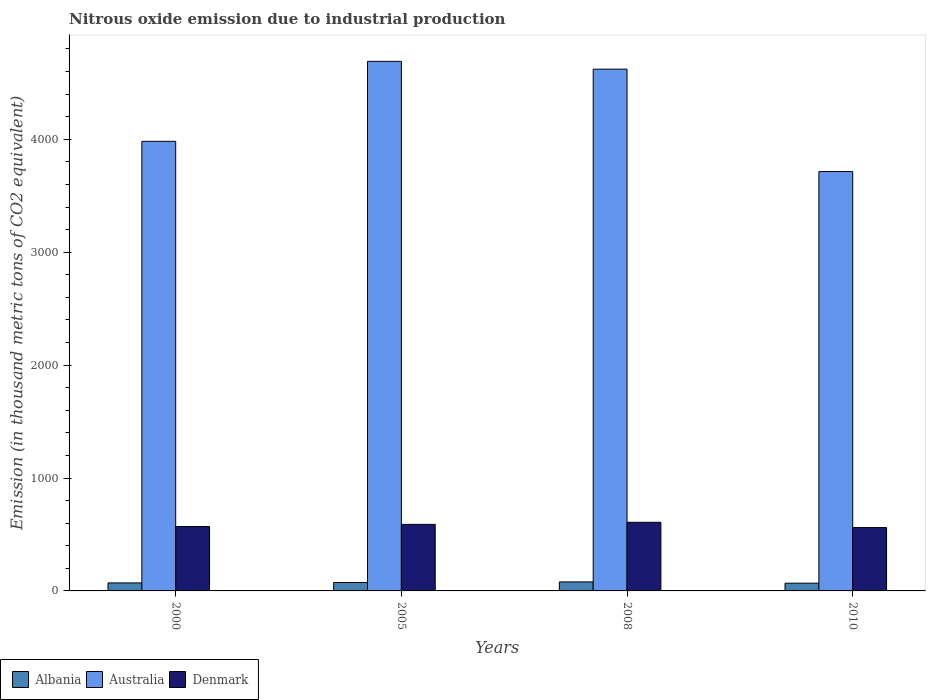Are the number of bars per tick equal to the number of legend labels?
Your answer should be very brief. Yes. How many bars are there on the 3rd tick from the left?
Ensure brevity in your answer.  3. How many bars are there on the 2nd tick from the right?
Your response must be concise. 3. What is the amount of nitrous oxide emitted in Albania in 2000?
Your answer should be compact. 70.9. Across all years, what is the maximum amount of nitrous oxide emitted in Albania?
Offer a terse response. 79.8. Across all years, what is the minimum amount of nitrous oxide emitted in Denmark?
Your answer should be compact. 561.1. What is the total amount of nitrous oxide emitted in Australia in the graph?
Ensure brevity in your answer.  1.70e+04. What is the difference between the amount of nitrous oxide emitted in Australia in 2008 and that in 2010?
Provide a succinct answer. 907. What is the difference between the amount of nitrous oxide emitted in Albania in 2008 and the amount of nitrous oxide emitted in Denmark in 2010?
Your answer should be compact. -481.3. What is the average amount of nitrous oxide emitted in Australia per year?
Make the answer very short. 4251.7. In the year 2010, what is the difference between the amount of nitrous oxide emitted in Australia and amount of nitrous oxide emitted in Denmark?
Offer a terse response. 3152.9. In how many years, is the amount of nitrous oxide emitted in Australia greater than 1400 thousand metric tons?
Provide a short and direct response. 4. What is the ratio of the amount of nitrous oxide emitted in Albania in 2000 to that in 2005?
Give a very brief answer. 0.95. Is the amount of nitrous oxide emitted in Denmark in 2008 less than that in 2010?
Provide a short and direct response. No. Is the difference between the amount of nitrous oxide emitted in Australia in 2005 and 2008 greater than the difference between the amount of nitrous oxide emitted in Denmark in 2005 and 2008?
Your answer should be compact. Yes. What is the difference between the highest and the second highest amount of nitrous oxide emitted in Denmark?
Make the answer very short. 18.4. What is the difference between the highest and the lowest amount of nitrous oxide emitted in Albania?
Your response must be concise. 11.3. What does the 1st bar from the left in 2005 represents?
Give a very brief answer. Albania. What does the 3rd bar from the right in 2000 represents?
Offer a terse response. Albania. How many years are there in the graph?
Your response must be concise. 4. What is the difference between two consecutive major ticks on the Y-axis?
Provide a short and direct response. 1000. Are the values on the major ticks of Y-axis written in scientific E-notation?
Offer a very short reply. No. Does the graph contain any zero values?
Your answer should be very brief. No. Where does the legend appear in the graph?
Your answer should be compact. Bottom left. How many legend labels are there?
Offer a terse response. 3. What is the title of the graph?
Ensure brevity in your answer.  Nitrous oxide emission due to industrial production. What is the label or title of the X-axis?
Provide a short and direct response. Years. What is the label or title of the Y-axis?
Your response must be concise. Emission (in thousand metric tons of CO2 equivalent). What is the Emission (in thousand metric tons of CO2 equivalent) of Albania in 2000?
Your answer should be very brief. 70.9. What is the Emission (in thousand metric tons of CO2 equivalent) of Australia in 2000?
Provide a succinct answer. 3981.7. What is the Emission (in thousand metric tons of CO2 equivalent) in Denmark in 2000?
Keep it short and to the point. 570.3. What is the Emission (in thousand metric tons of CO2 equivalent) in Albania in 2005?
Offer a terse response. 74.5. What is the Emission (in thousand metric tons of CO2 equivalent) in Australia in 2005?
Your answer should be compact. 4690.1. What is the Emission (in thousand metric tons of CO2 equivalent) of Denmark in 2005?
Provide a succinct answer. 589.4. What is the Emission (in thousand metric tons of CO2 equivalent) in Albania in 2008?
Give a very brief answer. 79.8. What is the Emission (in thousand metric tons of CO2 equivalent) of Australia in 2008?
Provide a succinct answer. 4621. What is the Emission (in thousand metric tons of CO2 equivalent) of Denmark in 2008?
Ensure brevity in your answer.  607.8. What is the Emission (in thousand metric tons of CO2 equivalent) of Albania in 2010?
Offer a terse response. 68.5. What is the Emission (in thousand metric tons of CO2 equivalent) in Australia in 2010?
Provide a succinct answer. 3714. What is the Emission (in thousand metric tons of CO2 equivalent) in Denmark in 2010?
Provide a succinct answer. 561.1. Across all years, what is the maximum Emission (in thousand metric tons of CO2 equivalent) in Albania?
Give a very brief answer. 79.8. Across all years, what is the maximum Emission (in thousand metric tons of CO2 equivalent) of Australia?
Make the answer very short. 4690.1. Across all years, what is the maximum Emission (in thousand metric tons of CO2 equivalent) of Denmark?
Provide a succinct answer. 607.8. Across all years, what is the minimum Emission (in thousand metric tons of CO2 equivalent) in Albania?
Provide a short and direct response. 68.5. Across all years, what is the minimum Emission (in thousand metric tons of CO2 equivalent) of Australia?
Provide a succinct answer. 3714. Across all years, what is the minimum Emission (in thousand metric tons of CO2 equivalent) in Denmark?
Provide a short and direct response. 561.1. What is the total Emission (in thousand metric tons of CO2 equivalent) in Albania in the graph?
Your response must be concise. 293.7. What is the total Emission (in thousand metric tons of CO2 equivalent) in Australia in the graph?
Keep it short and to the point. 1.70e+04. What is the total Emission (in thousand metric tons of CO2 equivalent) of Denmark in the graph?
Keep it short and to the point. 2328.6. What is the difference between the Emission (in thousand metric tons of CO2 equivalent) in Australia in 2000 and that in 2005?
Provide a short and direct response. -708.4. What is the difference between the Emission (in thousand metric tons of CO2 equivalent) in Denmark in 2000 and that in 2005?
Offer a very short reply. -19.1. What is the difference between the Emission (in thousand metric tons of CO2 equivalent) in Australia in 2000 and that in 2008?
Make the answer very short. -639.3. What is the difference between the Emission (in thousand metric tons of CO2 equivalent) in Denmark in 2000 and that in 2008?
Provide a succinct answer. -37.5. What is the difference between the Emission (in thousand metric tons of CO2 equivalent) of Australia in 2000 and that in 2010?
Provide a succinct answer. 267.7. What is the difference between the Emission (in thousand metric tons of CO2 equivalent) of Australia in 2005 and that in 2008?
Provide a short and direct response. 69.1. What is the difference between the Emission (in thousand metric tons of CO2 equivalent) of Denmark in 2005 and that in 2008?
Offer a terse response. -18.4. What is the difference between the Emission (in thousand metric tons of CO2 equivalent) of Albania in 2005 and that in 2010?
Ensure brevity in your answer.  6. What is the difference between the Emission (in thousand metric tons of CO2 equivalent) of Australia in 2005 and that in 2010?
Give a very brief answer. 976.1. What is the difference between the Emission (in thousand metric tons of CO2 equivalent) of Denmark in 2005 and that in 2010?
Your response must be concise. 28.3. What is the difference between the Emission (in thousand metric tons of CO2 equivalent) of Albania in 2008 and that in 2010?
Offer a terse response. 11.3. What is the difference between the Emission (in thousand metric tons of CO2 equivalent) in Australia in 2008 and that in 2010?
Your answer should be compact. 907. What is the difference between the Emission (in thousand metric tons of CO2 equivalent) in Denmark in 2008 and that in 2010?
Offer a very short reply. 46.7. What is the difference between the Emission (in thousand metric tons of CO2 equivalent) in Albania in 2000 and the Emission (in thousand metric tons of CO2 equivalent) in Australia in 2005?
Ensure brevity in your answer.  -4619.2. What is the difference between the Emission (in thousand metric tons of CO2 equivalent) in Albania in 2000 and the Emission (in thousand metric tons of CO2 equivalent) in Denmark in 2005?
Provide a short and direct response. -518.5. What is the difference between the Emission (in thousand metric tons of CO2 equivalent) in Australia in 2000 and the Emission (in thousand metric tons of CO2 equivalent) in Denmark in 2005?
Your answer should be compact. 3392.3. What is the difference between the Emission (in thousand metric tons of CO2 equivalent) in Albania in 2000 and the Emission (in thousand metric tons of CO2 equivalent) in Australia in 2008?
Keep it short and to the point. -4550.1. What is the difference between the Emission (in thousand metric tons of CO2 equivalent) in Albania in 2000 and the Emission (in thousand metric tons of CO2 equivalent) in Denmark in 2008?
Make the answer very short. -536.9. What is the difference between the Emission (in thousand metric tons of CO2 equivalent) of Australia in 2000 and the Emission (in thousand metric tons of CO2 equivalent) of Denmark in 2008?
Offer a terse response. 3373.9. What is the difference between the Emission (in thousand metric tons of CO2 equivalent) in Albania in 2000 and the Emission (in thousand metric tons of CO2 equivalent) in Australia in 2010?
Keep it short and to the point. -3643.1. What is the difference between the Emission (in thousand metric tons of CO2 equivalent) in Albania in 2000 and the Emission (in thousand metric tons of CO2 equivalent) in Denmark in 2010?
Offer a terse response. -490.2. What is the difference between the Emission (in thousand metric tons of CO2 equivalent) in Australia in 2000 and the Emission (in thousand metric tons of CO2 equivalent) in Denmark in 2010?
Provide a succinct answer. 3420.6. What is the difference between the Emission (in thousand metric tons of CO2 equivalent) in Albania in 2005 and the Emission (in thousand metric tons of CO2 equivalent) in Australia in 2008?
Your response must be concise. -4546.5. What is the difference between the Emission (in thousand metric tons of CO2 equivalent) of Albania in 2005 and the Emission (in thousand metric tons of CO2 equivalent) of Denmark in 2008?
Give a very brief answer. -533.3. What is the difference between the Emission (in thousand metric tons of CO2 equivalent) of Australia in 2005 and the Emission (in thousand metric tons of CO2 equivalent) of Denmark in 2008?
Provide a short and direct response. 4082.3. What is the difference between the Emission (in thousand metric tons of CO2 equivalent) in Albania in 2005 and the Emission (in thousand metric tons of CO2 equivalent) in Australia in 2010?
Make the answer very short. -3639.5. What is the difference between the Emission (in thousand metric tons of CO2 equivalent) in Albania in 2005 and the Emission (in thousand metric tons of CO2 equivalent) in Denmark in 2010?
Your answer should be compact. -486.6. What is the difference between the Emission (in thousand metric tons of CO2 equivalent) in Australia in 2005 and the Emission (in thousand metric tons of CO2 equivalent) in Denmark in 2010?
Offer a very short reply. 4129. What is the difference between the Emission (in thousand metric tons of CO2 equivalent) in Albania in 2008 and the Emission (in thousand metric tons of CO2 equivalent) in Australia in 2010?
Keep it short and to the point. -3634.2. What is the difference between the Emission (in thousand metric tons of CO2 equivalent) in Albania in 2008 and the Emission (in thousand metric tons of CO2 equivalent) in Denmark in 2010?
Keep it short and to the point. -481.3. What is the difference between the Emission (in thousand metric tons of CO2 equivalent) of Australia in 2008 and the Emission (in thousand metric tons of CO2 equivalent) of Denmark in 2010?
Offer a terse response. 4059.9. What is the average Emission (in thousand metric tons of CO2 equivalent) of Albania per year?
Give a very brief answer. 73.42. What is the average Emission (in thousand metric tons of CO2 equivalent) in Australia per year?
Give a very brief answer. 4251.7. What is the average Emission (in thousand metric tons of CO2 equivalent) of Denmark per year?
Offer a very short reply. 582.15. In the year 2000, what is the difference between the Emission (in thousand metric tons of CO2 equivalent) in Albania and Emission (in thousand metric tons of CO2 equivalent) in Australia?
Offer a very short reply. -3910.8. In the year 2000, what is the difference between the Emission (in thousand metric tons of CO2 equivalent) of Albania and Emission (in thousand metric tons of CO2 equivalent) of Denmark?
Keep it short and to the point. -499.4. In the year 2000, what is the difference between the Emission (in thousand metric tons of CO2 equivalent) of Australia and Emission (in thousand metric tons of CO2 equivalent) of Denmark?
Make the answer very short. 3411.4. In the year 2005, what is the difference between the Emission (in thousand metric tons of CO2 equivalent) in Albania and Emission (in thousand metric tons of CO2 equivalent) in Australia?
Offer a terse response. -4615.6. In the year 2005, what is the difference between the Emission (in thousand metric tons of CO2 equivalent) in Albania and Emission (in thousand metric tons of CO2 equivalent) in Denmark?
Your answer should be very brief. -514.9. In the year 2005, what is the difference between the Emission (in thousand metric tons of CO2 equivalent) of Australia and Emission (in thousand metric tons of CO2 equivalent) of Denmark?
Your answer should be compact. 4100.7. In the year 2008, what is the difference between the Emission (in thousand metric tons of CO2 equivalent) in Albania and Emission (in thousand metric tons of CO2 equivalent) in Australia?
Ensure brevity in your answer.  -4541.2. In the year 2008, what is the difference between the Emission (in thousand metric tons of CO2 equivalent) in Albania and Emission (in thousand metric tons of CO2 equivalent) in Denmark?
Provide a short and direct response. -528. In the year 2008, what is the difference between the Emission (in thousand metric tons of CO2 equivalent) in Australia and Emission (in thousand metric tons of CO2 equivalent) in Denmark?
Provide a succinct answer. 4013.2. In the year 2010, what is the difference between the Emission (in thousand metric tons of CO2 equivalent) in Albania and Emission (in thousand metric tons of CO2 equivalent) in Australia?
Your answer should be compact. -3645.5. In the year 2010, what is the difference between the Emission (in thousand metric tons of CO2 equivalent) of Albania and Emission (in thousand metric tons of CO2 equivalent) of Denmark?
Offer a very short reply. -492.6. In the year 2010, what is the difference between the Emission (in thousand metric tons of CO2 equivalent) in Australia and Emission (in thousand metric tons of CO2 equivalent) in Denmark?
Offer a very short reply. 3152.9. What is the ratio of the Emission (in thousand metric tons of CO2 equivalent) of Albania in 2000 to that in 2005?
Ensure brevity in your answer.  0.95. What is the ratio of the Emission (in thousand metric tons of CO2 equivalent) in Australia in 2000 to that in 2005?
Provide a succinct answer. 0.85. What is the ratio of the Emission (in thousand metric tons of CO2 equivalent) in Denmark in 2000 to that in 2005?
Your answer should be very brief. 0.97. What is the ratio of the Emission (in thousand metric tons of CO2 equivalent) in Albania in 2000 to that in 2008?
Provide a succinct answer. 0.89. What is the ratio of the Emission (in thousand metric tons of CO2 equivalent) of Australia in 2000 to that in 2008?
Offer a very short reply. 0.86. What is the ratio of the Emission (in thousand metric tons of CO2 equivalent) of Denmark in 2000 to that in 2008?
Offer a very short reply. 0.94. What is the ratio of the Emission (in thousand metric tons of CO2 equivalent) in Albania in 2000 to that in 2010?
Provide a succinct answer. 1.03. What is the ratio of the Emission (in thousand metric tons of CO2 equivalent) of Australia in 2000 to that in 2010?
Offer a very short reply. 1.07. What is the ratio of the Emission (in thousand metric tons of CO2 equivalent) of Denmark in 2000 to that in 2010?
Your answer should be compact. 1.02. What is the ratio of the Emission (in thousand metric tons of CO2 equivalent) of Albania in 2005 to that in 2008?
Your response must be concise. 0.93. What is the ratio of the Emission (in thousand metric tons of CO2 equivalent) of Denmark in 2005 to that in 2008?
Provide a succinct answer. 0.97. What is the ratio of the Emission (in thousand metric tons of CO2 equivalent) in Albania in 2005 to that in 2010?
Offer a terse response. 1.09. What is the ratio of the Emission (in thousand metric tons of CO2 equivalent) in Australia in 2005 to that in 2010?
Offer a very short reply. 1.26. What is the ratio of the Emission (in thousand metric tons of CO2 equivalent) in Denmark in 2005 to that in 2010?
Give a very brief answer. 1.05. What is the ratio of the Emission (in thousand metric tons of CO2 equivalent) in Albania in 2008 to that in 2010?
Make the answer very short. 1.17. What is the ratio of the Emission (in thousand metric tons of CO2 equivalent) in Australia in 2008 to that in 2010?
Your answer should be compact. 1.24. What is the ratio of the Emission (in thousand metric tons of CO2 equivalent) of Denmark in 2008 to that in 2010?
Your answer should be very brief. 1.08. What is the difference between the highest and the second highest Emission (in thousand metric tons of CO2 equivalent) of Albania?
Offer a terse response. 5.3. What is the difference between the highest and the second highest Emission (in thousand metric tons of CO2 equivalent) of Australia?
Offer a very short reply. 69.1. What is the difference between the highest and the lowest Emission (in thousand metric tons of CO2 equivalent) in Albania?
Your response must be concise. 11.3. What is the difference between the highest and the lowest Emission (in thousand metric tons of CO2 equivalent) in Australia?
Keep it short and to the point. 976.1. What is the difference between the highest and the lowest Emission (in thousand metric tons of CO2 equivalent) in Denmark?
Provide a short and direct response. 46.7. 